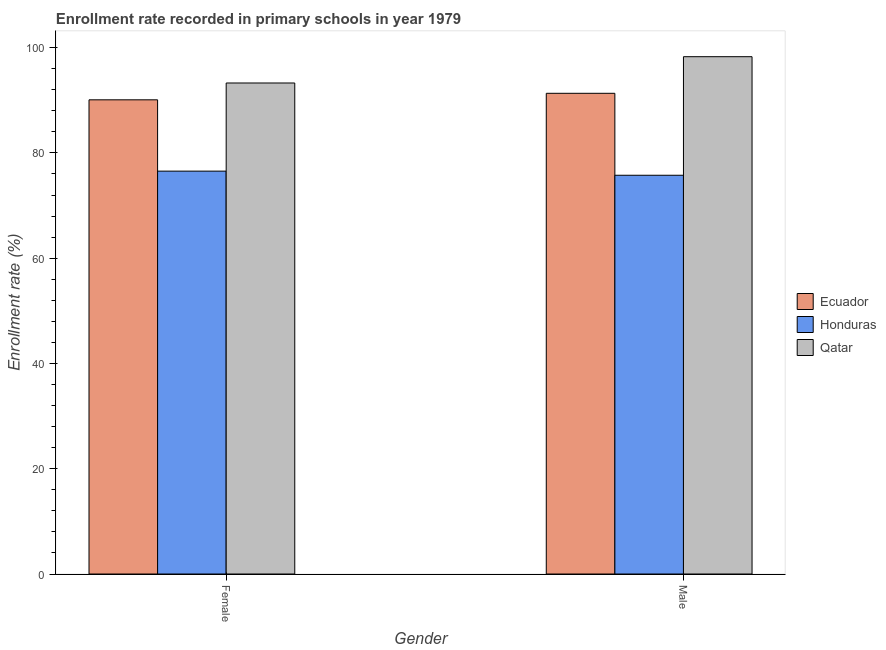How many different coloured bars are there?
Ensure brevity in your answer.  3. How many bars are there on the 2nd tick from the left?
Make the answer very short. 3. What is the label of the 1st group of bars from the left?
Offer a very short reply. Female. What is the enrollment rate of female students in Qatar?
Give a very brief answer. 93.29. Across all countries, what is the maximum enrollment rate of male students?
Offer a terse response. 98.28. Across all countries, what is the minimum enrollment rate of female students?
Your answer should be very brief. 76.54. In which country was the enrollment rate of female students maximum?
Keep it short and to the point. Qatar. In which country was the enrollment rate of female students minimum?
Your response must be concise. Honduras. What is the total enrollment rate of female students in the graph?
Keep it short and to the point. 259.92. What is the difference between the enrollment rate of male students in Ecuador and that in Honduras?
Your answer should be compact. 15.57. What is the difference between the enrollment rate of male students in Honduras and the enrollment rate of female students in Qatar?
Provide a short and direct response. -17.53. What is the average enrollment rate of female students per country?
Provide a succinct answer. 86.64. What is the difference between the enrollment rate of female students and enrollment rate of male students in Ecuador?
Keep it short and to the point. -1.24. What is the ratio of the enrollment rate of male students in Qatar to that in Honduras?
Your response must be concise. 1.3. What does the 1st bar from the left in Male represents?
Keep it short and to the point. Ecuador. What does the 1st bar from the right in Female represents?
Your answer should be compact. Qatar. How many countries are there in the graph?
Your answer should be compact. 3. Are the values on the major ticks of Y-axis written in scientific E-notation?
Provide a succinct answer. No. Does the graph contain any zero values?
Your response must be concise. No. Does the graph contain grids?
Make the answer very short. No. How many legend labels are there?
Keep it short and to the point. 3. What is the title of the graph?
Offer a terse response. Enrollment rate recorded in primary schools in year 1979. Does "Cote d'Ivoire" appear as one of the legend labels in the graph?
Offer a terse response. No. What is the label or title of the Y-axis?
Offer a very short reply. Enrollment rate (%). What is the Enrollment rate (%) in Ecuador in Female?
Provide a succinct answer. 90.09. What is the Enrollment rate (%) of Honduras in Female?
Provide a short and direct response. 76.54. What is the Enrollment rate (%) in Qatar in Female?
Offer a terse response. 93.29. What is the Enrollment rate (%) of Ecuador in Male?
Give a very brief answer. 91.33. What is the Enrollment rate (%) of Honduras in Male?
Offer a terse response. 75.76. What is the Enrollment rate (%) in Qatar in Male?
Your answer should be very brief. 98.28. Across all Gender, what is the maximum Enrollment rate (%) in Ecuador?
Make the answer very short. 91.33. Across all Gender, what is the maximum Enrollment rate (%) in Honduras?
Keep it short and to the point. 76.54. Across all Gender, what is the maximum Enrollment rate (%) in Qatar?
Your answer should be very brief. 98.28. Across all Gender, what is the minimum Enrollment rate (%) of Ecuador?
Make the answer very short. 90.09. Across all Gender, what is the minimum Enrollment rate (%) in Honduras?
Make the answer very short. 75.76. Across all Gender, what is the minimum Enrollment rate (%) of Qatar?
Keep it short and to the point. 93.29. What is the total Enrollment rate (%) in Ecuador in the graph?
Your response must be concise. 181.42. What is the total Enrollment rate (%) in Honduras in the graph?
Give a very brief answer. 152.3. What is the total Enrollment rate (%) in Qatar in the graph?
Your answer should be very brief. 191.57. What is the difference between the Enrollment rate (%) in Ecuador in Female and that in Male?
Make the answer very short. -1.24. What is the difference between the Enrollment rate (%) in Honduras in Female and that in Male?
Provide a succinct answer. 0.78. What is the difference between the Enrollment rate (%) of Qatar in Female and that in Male?
Your response must be concise. -5. What is the difference between the Enrollment rate (%) in Ecuador in Female and the Enrollment rate (%) in Honduras in Male?
Provide a succinct answer. 14.33. What is the difference between the Enrollment rate (%) of Ecuador in Female and the Enrollment rate (%) of Qatar in Male?
Provide a succinct answer. -8.19. What is the difference between the Enrollment rate (%) of Honduras in Female and the Enrollment rate (%) of Qatar in Male?
Your answer should be compact. -21.74. What is the average Enrollment rate (%) of Ecuador per Gender?
Provide a succinct answer. 90.71. What is the average Enrollment rate (%) of Honduras per Gender?
Give a very brief answer. 76.15. What is the average Enrollment rate (%) of Qatar per Gender?
Provide a succinct answer. 95.79. What is the difference between the Enrollment rate (%) in Ecuador and Enrollment rate (%) in Honduras in Female?
Provide a succinct answer. 13.55. What is the difference between the Enrollment rate (%) in Ecuador and Enrollment rate (%) in Qatar in Female?
Make the answer very short. -3.2. What is the difference between the Enrollment rate (%) in Honduras and Enrollment rate (%) in Qatar in Female?
Offer a very short reply. -16.75. What is the difference between the Enrollment rate (%) in Ecuador and Enrollment rate (%) in Honduras in Male?
Keep it short and to the point. 15.57. What is the difference between the Enrollment rate (%) of Ecuador and Enrollment rate (%) of Qatar in Male?
Ensure brevity in your answer.  -6.96. What is the difference between the Enrollment rate (%) of Honduras and Enrollment rate (%) of Qatar in Male?
Provide a succinct answer. -22.53. What is the ratio of the Enrollment rate (%) of Ecuador in Female to that in Male?
Your answer should be very brief. 0.99. What is the ratio of the Enrollment rate (%) in Honduras in Female to that in Male?
Give a very brief answer. 1.01. What is the ratio of the Enrollment rate (%) in Qatar in Female to that in Male?
Your answer should be compact. 0.95. What is the difference between the highest and the second highest Enrollment rate (%) of Ecuador?
Your response must be concise. 1.24. What is the difference between the highest and the second highest Enrollment rate (%) of Honduras?
Offer a very short reply. 0.78. What is the difference between the highest and the second highest Enrollment rate (%) of Qatar?
Make the answer very short. 5. What is the difference between the highest and the lowest Enrollment rate (%) of Ecuador?
Keep it short and to the point. 1.24. What is the difference between the highest and the lowest Enrollment rate (%) in Honduras?
Provide a succinct answer. 0.78. What is the difference between the highest and the lowest Enrollment rate (%) in Qatar?
Your answer should be very brief. 5. 